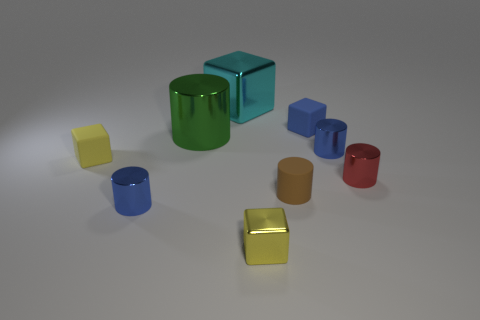Subtract all green cylinders. How many cylinders are left? 4 Add 1 large gray matte blocks. How many objects exist? 10 Subtract all blue cubes. How many cubes are left? 3 Subtract 4 cylinders. How many cylinders are left? 1 Subtract all green metallic cylinders. Subtract all large green objects. How many objects are left? 7 Add 1 yellow rubber cubes. How many yellow rubber cubes are left? 2 Add 9 small blue matte objects. How many small blue matte objects exist? 10 Subtract 0 brown spheres. How many objects are left? 9 Subtract all blocks. How many objects are left? 5 Subtract all yellow cylinders. Subtract all gray cubes. How many cylinders are left? 5 